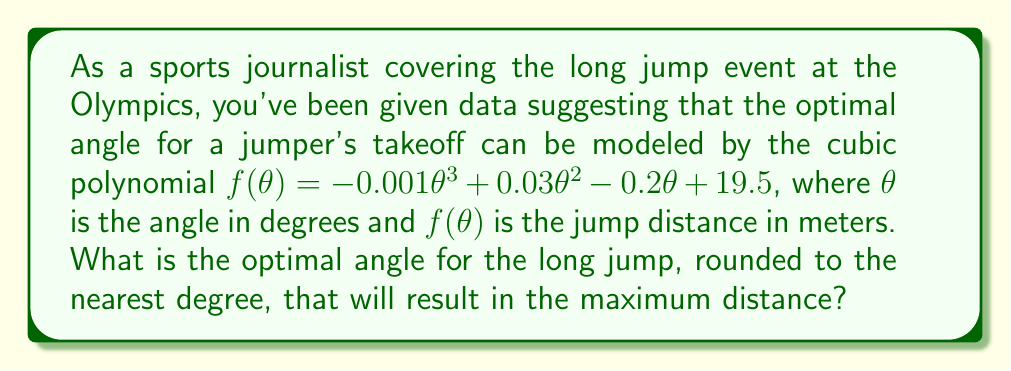Solve this math problem. To find the optimal angle for the long jump, we need to determine the maximum point of the given cubic function. This can be done by following these steps:

1) First, we need to find the derivative of the function:
   $f'(\theta) = -0.003\theta^2 + 0.06\theta - 0.2$

2) The maximum point occurs where the derivative equals zero. So, we set $f'(\theta) = 0$:
   $-0.003\theta^2 + 0.06\theta - 0.2 = 0$

3) This is a quadratic equation. We can solve it using the quadratic formula:
   $\theta = \frac{-b \pm \sqrt{b^2 - 4ac}}{2a}$

   Where $a = -0.003$, $b = 0.06$, and $c = -0.2$

4) Substituting these values:
   $\theta = \frac{-0.06 \pm \sqrt{0.06^2 - 4(-0.003)(-0.2)}}{2(-0.003)}$

5) Simplifying:
   $\theta = \frac{-0.06 \pm \sqrt{0.0036 - 0.0024}}{-0.006}$
   $\theta = \frac{-0.06 \pm \sqrt{0.0012}}{-0.006}$
   $\theta = \frac{-0.06 \pm 0.0346}{-0.006}$

6) This gives us two solutions:
   $\theta_1 = \frac{-0.06 + 0.0346}{-0.006} \approx 4.23$
   $\theta_2 = \frac{-0.06 - 0.0346}{-0.006} \approx 15.77$

7) To determine which of these is the maximum (rather than the minimum), we can check the second derivative:
   $f''(\theta) = -0.006\theta + 0.06$

   At $\theta = 15.77$, $f''(15.77) < 0$, indicating this is a maximum.

8) Rounding to the nearest degree, we get 16°.
Answer: The optimal angle for the long jump, rounded to the nearest degree, is 16°. 